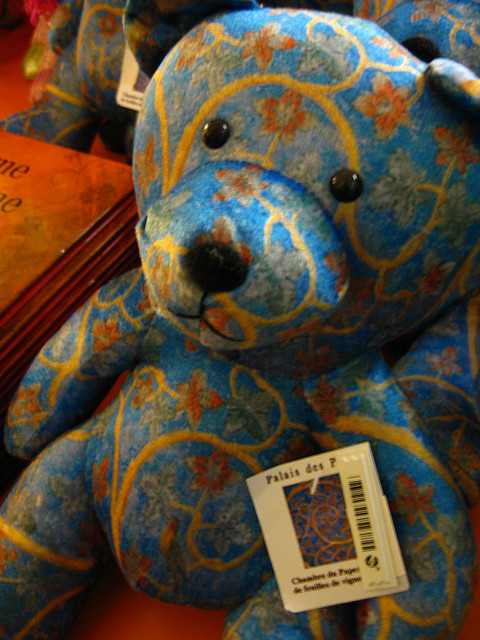Identify and read out the text in this image. me Palais 